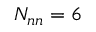<formula> <loc_0><loc_0><loc_500><loc_500>N _ { n n } = 6</formula> 